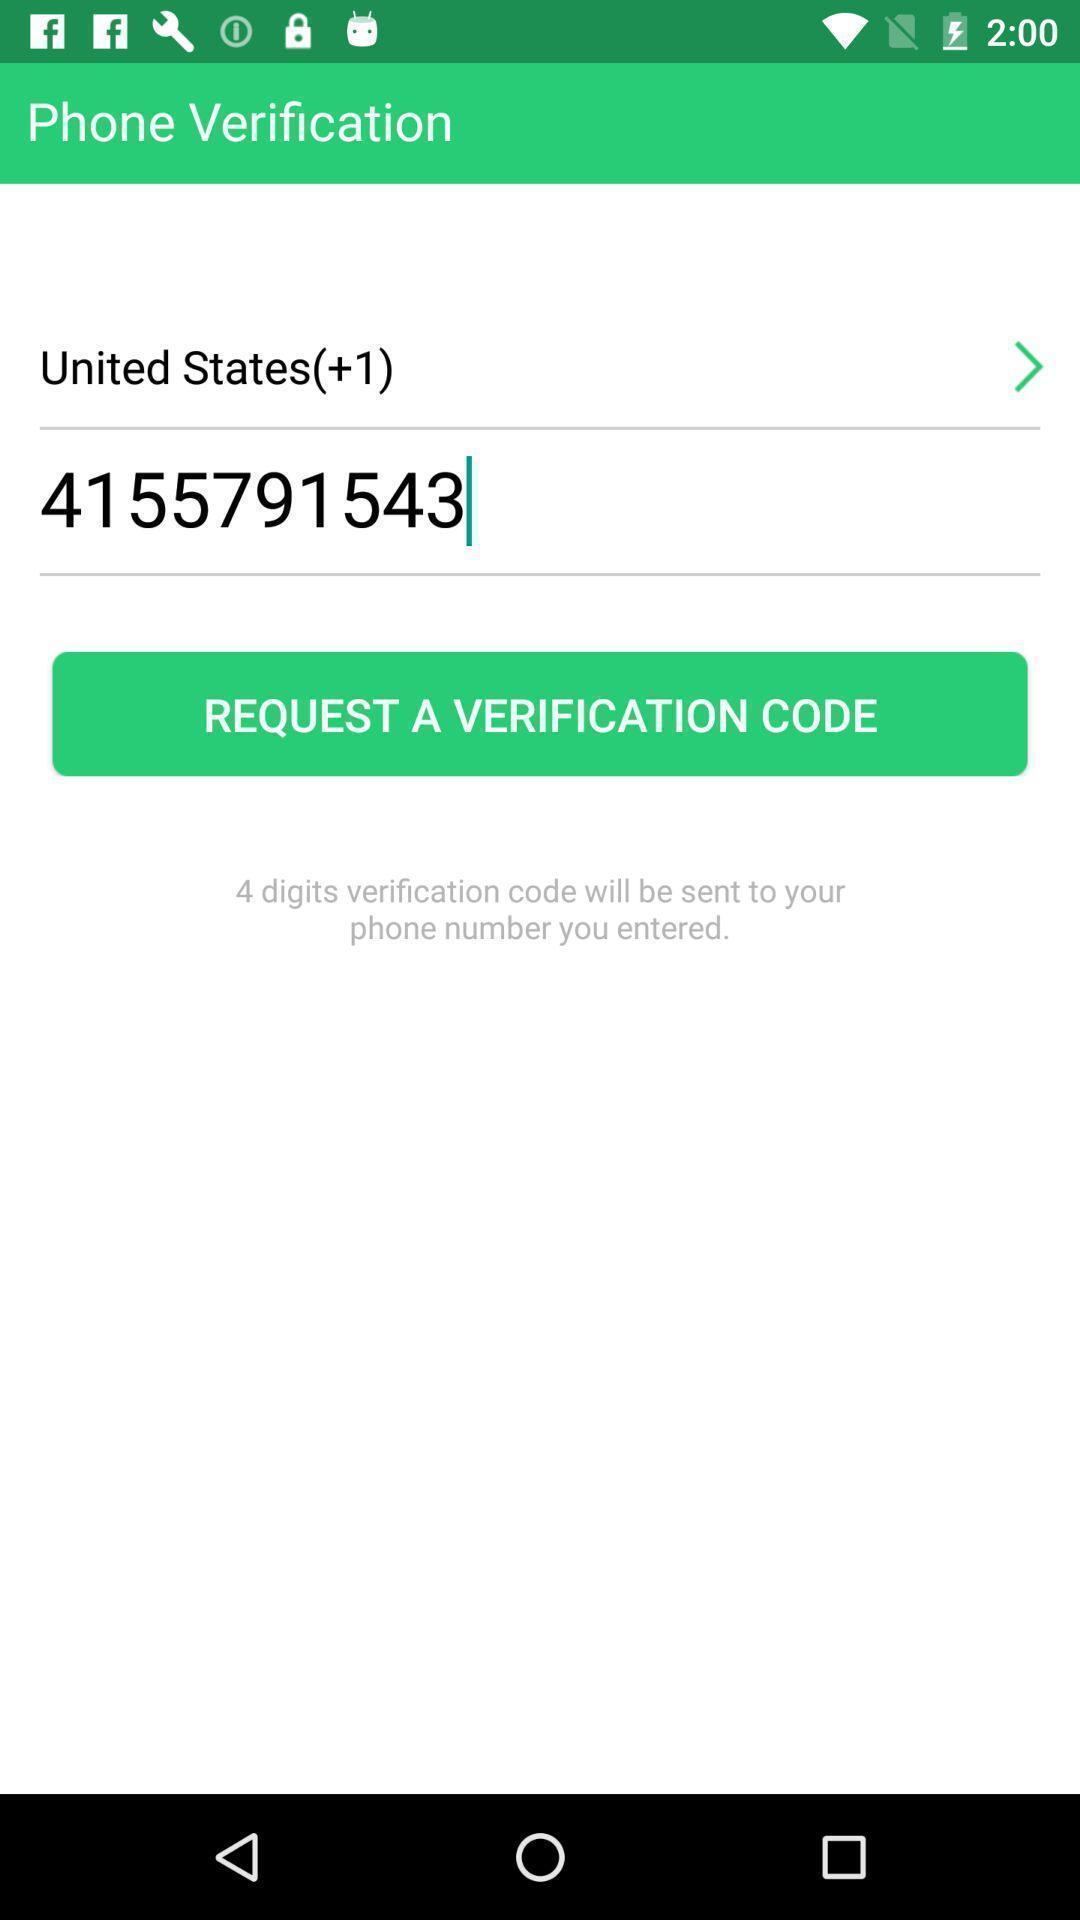Describe the content in this image. Screen shows phone verification details. 